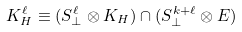Convert formula to latex. <formula><loc_0><loc_0><loc_500><loc_500>K _ { H } ^ { \ell } \equiv ( S _ { \perp } ^ { \ell } \otimes K _ { H } ) \cap ( S _ { \perp } ^ { k + \ell } \otimes E )</formula> 